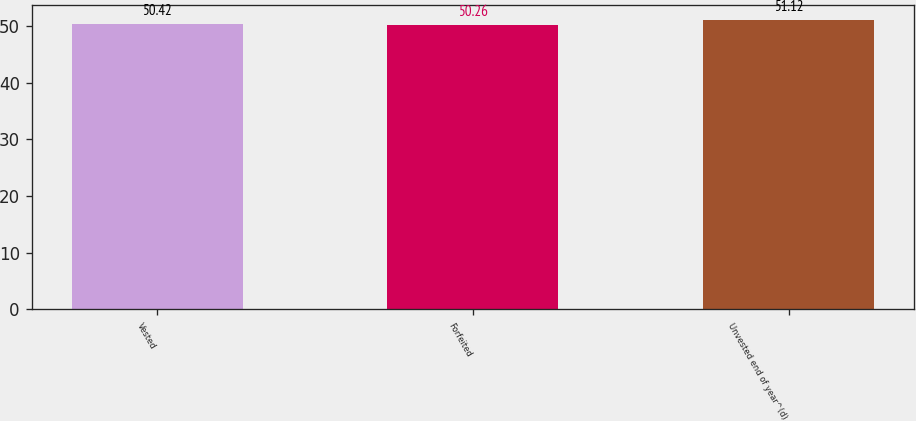Convert chart to OTSL. <chart><loc_0><loc_0><loc_500><loc_500><bar_chart><fcel>Vested<fcel>Forfeited<fcel>Unvested end of year^(d)<nl><fcel>50.42<fcel>50.26<fcel>51.12<nl></chart> 